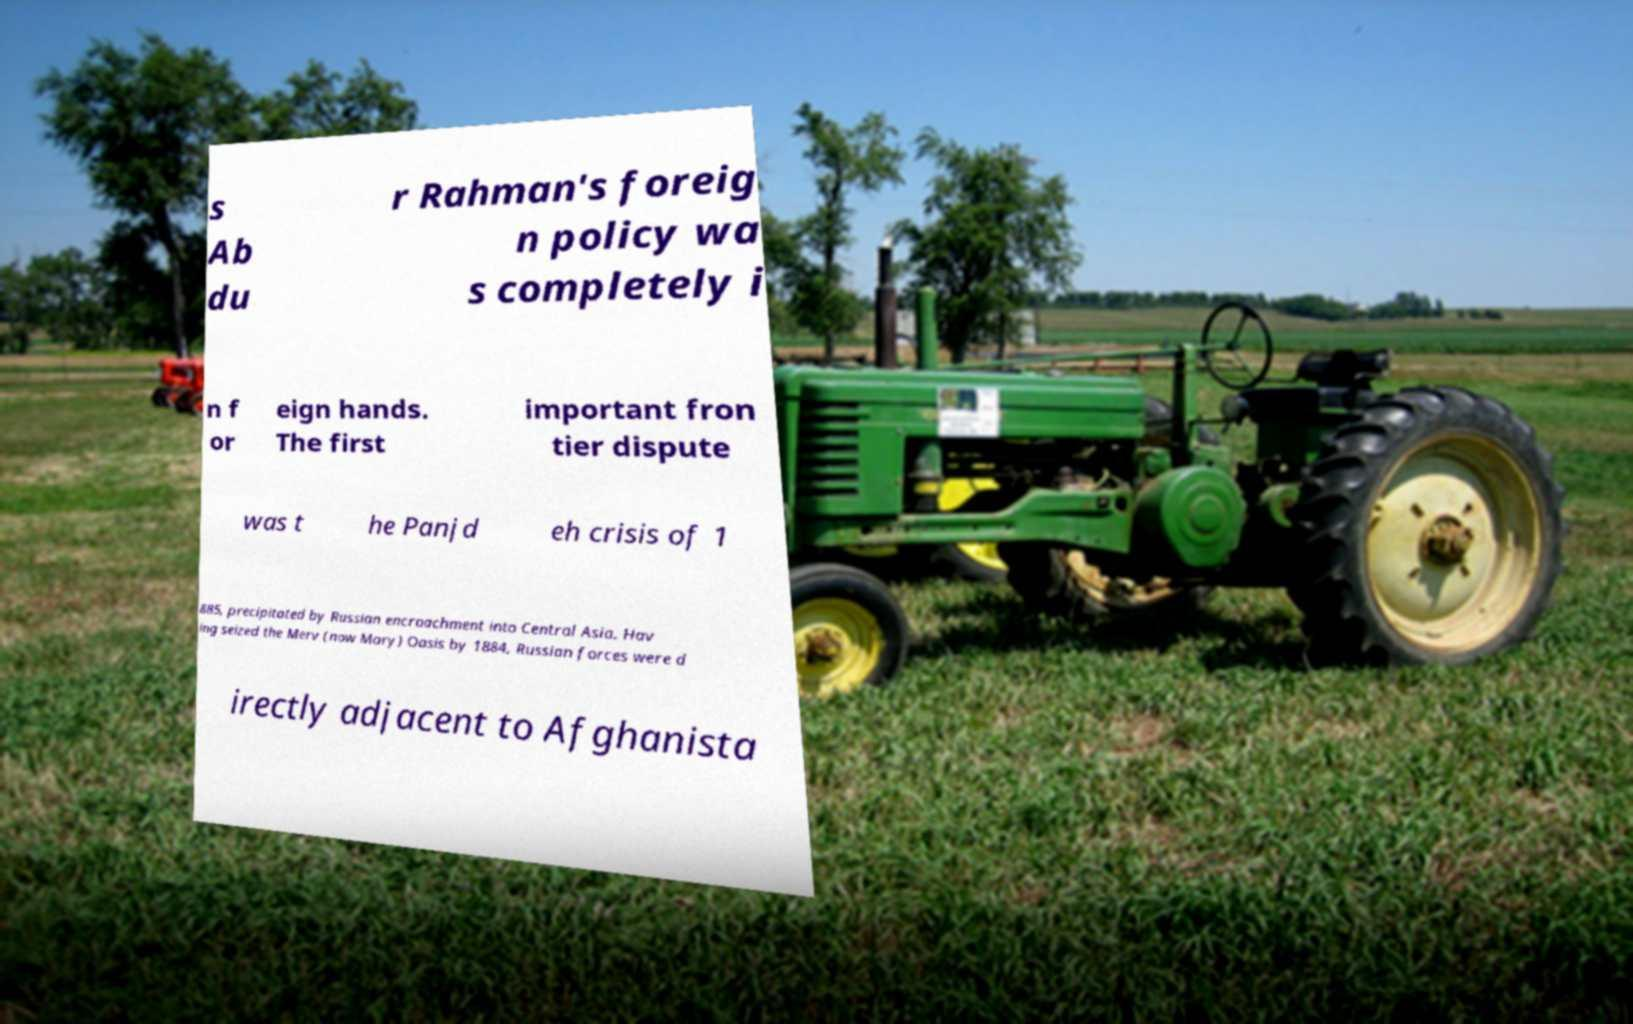For documentation purposes, I need the text within this image transcribed. Could you provide that? s Ab du r Rahman's foreig n policy wa s completely i n f or eign hands. The first important fron tier dispute was t he Panjd eh crisis of 1 885, precipitated by Russian encroachment into Central Asia. Hav ing seized the Merv (now Mary) Oasis by 1884, Russian forces were d irectly adjacent to Afghanista 